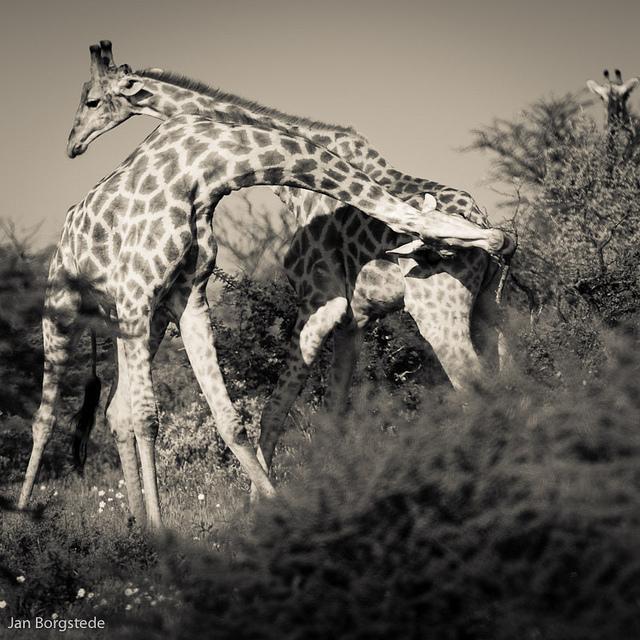How many giraffes are there?
Give a very brief answer. 2. 